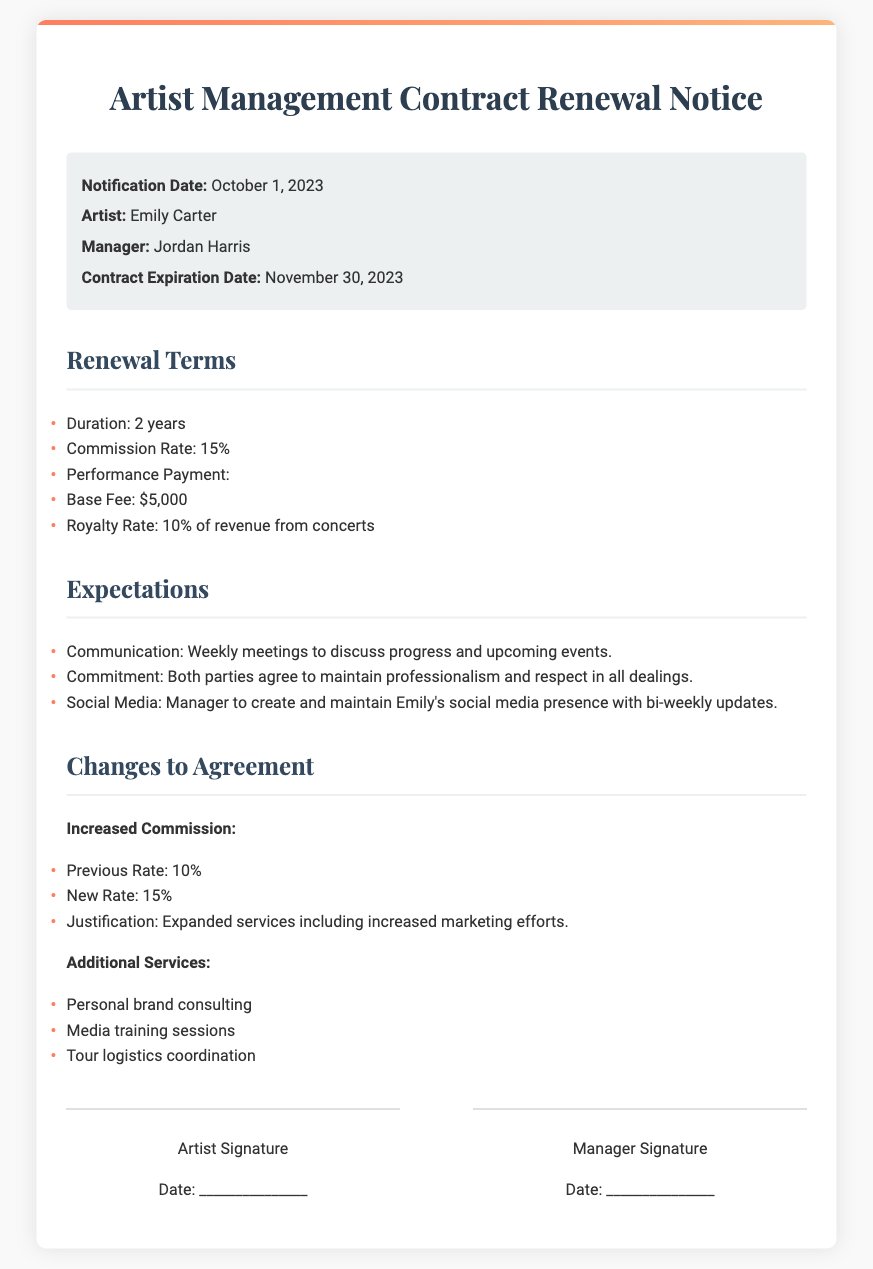What is the notification date? The notification date is clearly stated in the document as the date when the notice is issued.
Answer: October 1, 2023 Who is the artist mentioned in the contract? The artist's name is provided in the introductory section of the document.
Answer: Emily Carter What is the commission rate after renewal? The commission rate is specified in the renewal terms section.
Answer: 15% What is the base fee for performance payment? The base fee is listed under the performance payment terms in the document.
Answer: $5,000 What are the additional services included in the renewal? The additional services are listed explicitly towards the end of the contract renewal notice.
Answer: Personal brand consulting, Media training sessions, Tour logistics coordination How long is the renewed contract duration? The duration of the renewed contract is mentioned in the renewal terms.
Answer: 2 years What is the previous commission rate? The previous commission rate is indicated as a comparison to the new rate in the document.
Answer: 10% What is the expected frequency of meetings according to the expectations? The frequency of meetings is outlined in the expectations section of the document.
Answer: Weekly meetings What is the royalty rate from concert revenue? The royalty rate from concert revenue is provided in the performance payment terms section.
Answer: 10% 